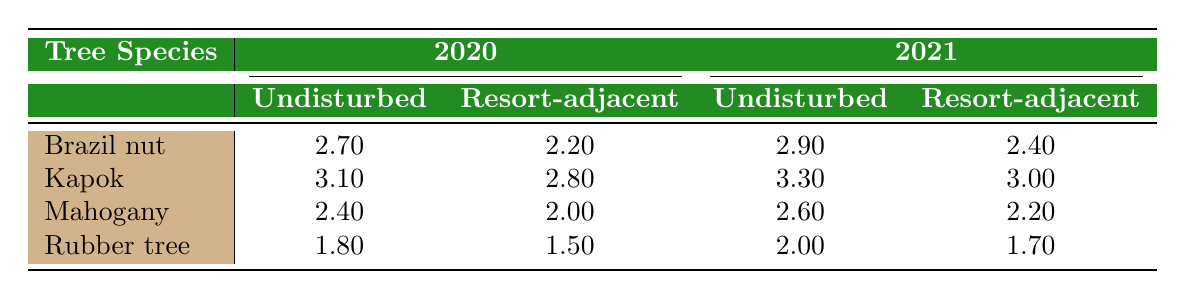What is the carbon sequestration rate of Brazil nut trees in undisturbed areas for 2020? The table shows that in the year 2020, the carbon sequestration rate for Brazil nut trees in undisturbed areas is 2.70.
Answer: 2.70 What is the carbon sequestration rate of Mahogany trees in resort-adjacent areas for 2021? According to the table, Mahogany trees in resort-adjacent areas had a carbon sequestration rate of 2.20 for the year 2021.
Answer: 2.20 Which tree species had the highest carbon sequestration rate in undisturbed areas in 2020? Looking at the table, the Kapok species had the highest carbon sequestration rate in undisturbed areas in 2020, which is 3.10.
Answer: Kapok Is the carbon sequestration rate of Rubber tree species in resort-adjacent areas higher in 2020 or 2021? By comparing the values in the table, the carbon sequestration rate for Rubber trees in resort-adjacent areas is lower in 2021 (1.70) than in 2020 (1.50).
Answer: 2020 What is the average carbon sequestration rate of Kapok trees for the years 2020 and 2021 in undisturbed areas? First, the values for Kapok in undisturbed areas are 3.10 (2020) and 3.30 (2021). Summing them gives 3.10 + 3.30 = 6.40. Then, dividing by 2 for the average results in 6.40 / 2 = 3.20.
Answer: 3.20 Did any tree species have the same carbon sequestration rate in both years for undisturbed areas? In the table, each species had different rates in undisturbed areas between the years 2020 and 2021, hence none of them maintained the same rate.
Answer: No Which tree species experienced the greatest drop in carbon sequestration rate from undisturbed to resort-adjacent for the year 2020? The Brazil nut tree had a drop from 2.70 in undisturbed to 2.20 in resort-adjacent, which is a difference of 0.50. This is the greatest drop observed for the species over this comparison.
Answer: Brazil nut Is the carbon sequestration rate for Kapok trees consistently higher than that of Rubber trees in both years? Evaluating the table, in both 2020 and 2021, Kapok trees showed higher rates (3.10 and 3.30) as compared to Rubber trees (1.80 and 2.00) respectively, thus confirming that they are consistently higher.
Answer: Yes What is the difference in carbon sequestration rates for Mahogany trees between undisturbed and resort-adjacent areas in 2021? The table indicates that in 2021, Mahogany in undisturbed areas had a rate of 2.60, while in resort-adjacent areas it was 2.20. The difference is 2.60 - 2.20 = 0.40.
Answer: 0.40 